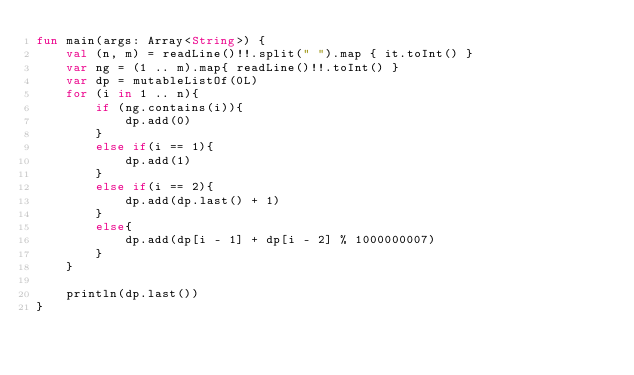Convert code to text. <code><loc_0><loc_0><loc_500><loc_500><_Kotlin_>fun main(args: Array<String>) {
    val (n, m) = readLine()!!.split(" ").map { it.toInt() }
    var ng = (1 .. m).map{ readLine()!!.toInt() }
    var dp = mutableListOf(0L)
    for (i in 1 .. n){
        if (ng.contains(i)){
            dp.add(0)
        }
        else if(i == 1){
            dp.add(1)
        }
        else if(i == 2){
            dp.add(dp.last() + 1)
        }
        else{
            dp.add(dp[i - 1] + dp[i - 2] % 1000000007)
        }
    }

    println(dp.last())
}</code> 